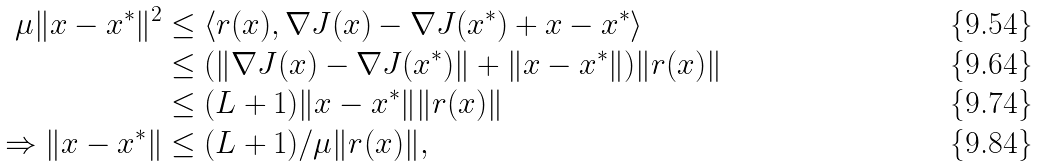Convert formula to latex. <formula><loc_0><loc_0><loc_500><loc_500>\mu \| x - x ^ { * } \| ^ { 2 } & \leq \langle r ( x ) , \nabla J ( x ) - \nabla J ( x ^ { * } ) + x - x ^ { * } \rangle \\ & \leq ( \| \nabla J ( x ) - \nabla J ( x ^ { * } ) \| + \| x - x ^ { * } \| ) \| r ( x ) \| \\ & \leq ( L + 1 ) \| x - x ^ { * } \| \| r ( x ) \| \\ \Rightarrow \| x - x ^ { * } \| & \leq ( L + 1 ) / \mu \| r ( x ) \| ,</formula> 